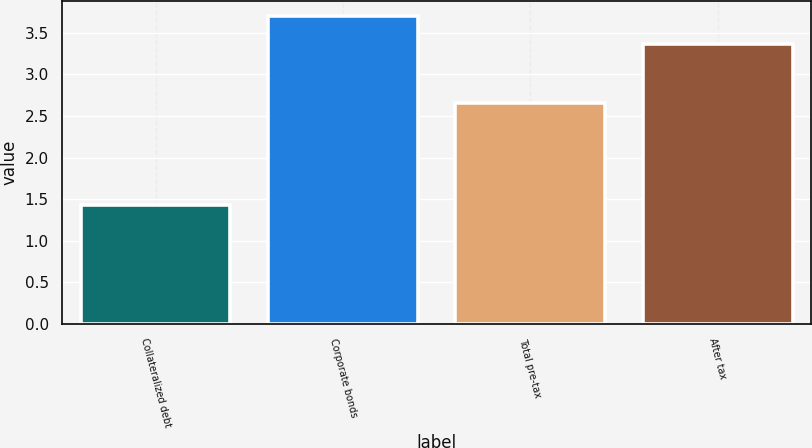Convert chart to OTSL. <chart><loc_0><loc_0><loc_500><loc_500><bar_chart><fcel>Collateralized debt<fcel>Corporate bonds<fcel>Total pre-tax<fcel>After tax<nl><fcel>1.43<fcel>3.7<fcel>2.66<fcel>3.36<nl></chart> 